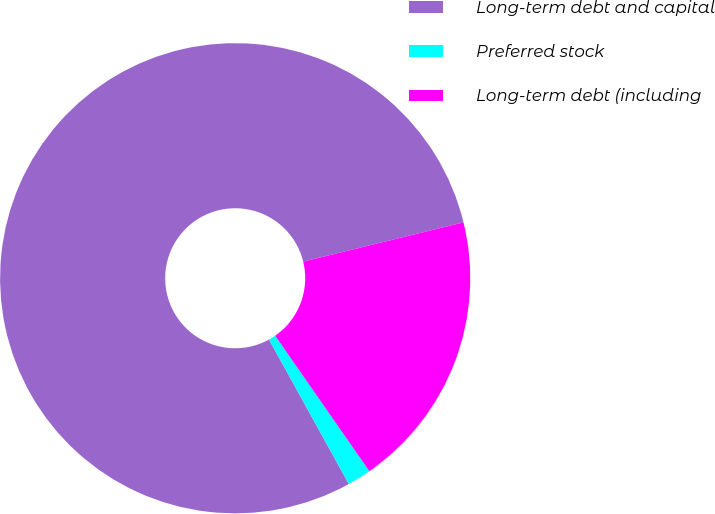Convert chart. <chart><loc_0><loc_0><loc_500><loc_500><pie_chart><fcel>Long-term debt and capital<fcel>Preferred stock<fcel>Long-term debt (including<nl><fcel>79.21%<fcel>1.64%<fcel>19.15%<nl></chart> 